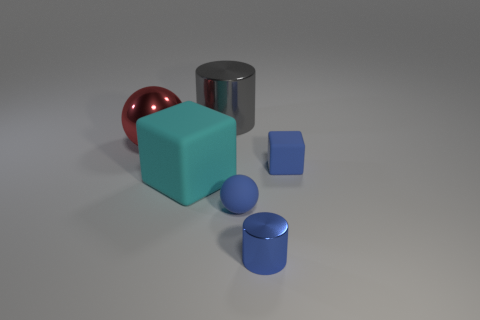What number of large cubes have the same material as the large red object?
Your answer should be compact. 0. Is the color of the large rubber object the same as the large metallic thing right of the red ball?
Your answer should be compact. No. The big object behind the large metal thing that is in front of the gray shiny thing is what color?
Your response must be concise. Gray. The rubber object that is the same size as the red shiny ball is what color?
Ensure brevity in your answer.  Cyan. Are there any other tiny blue shiny things that have the same shape as the blue metal thing?
Give a very brief answer. No. What shape is the gray object?
Give a very brief answer. Cylinder. Is the number of gray cylinders on the right side of the blue shiny cylinder greater than the number of large cyan cubes that are right of the tiny sphere?
Your answer should be compact. No. How many other objects are the same size as the blue cylinder?
Give a very brief answer. 2. What is the object that is to the left of the blue shiny cylinder and in front of the large cyan rubber object made of?
Give a very brief answer. Rubber. There is a small blue thing that is the same shape as the large cyan object; what is its material?
Your response must be concise. Rubber. 